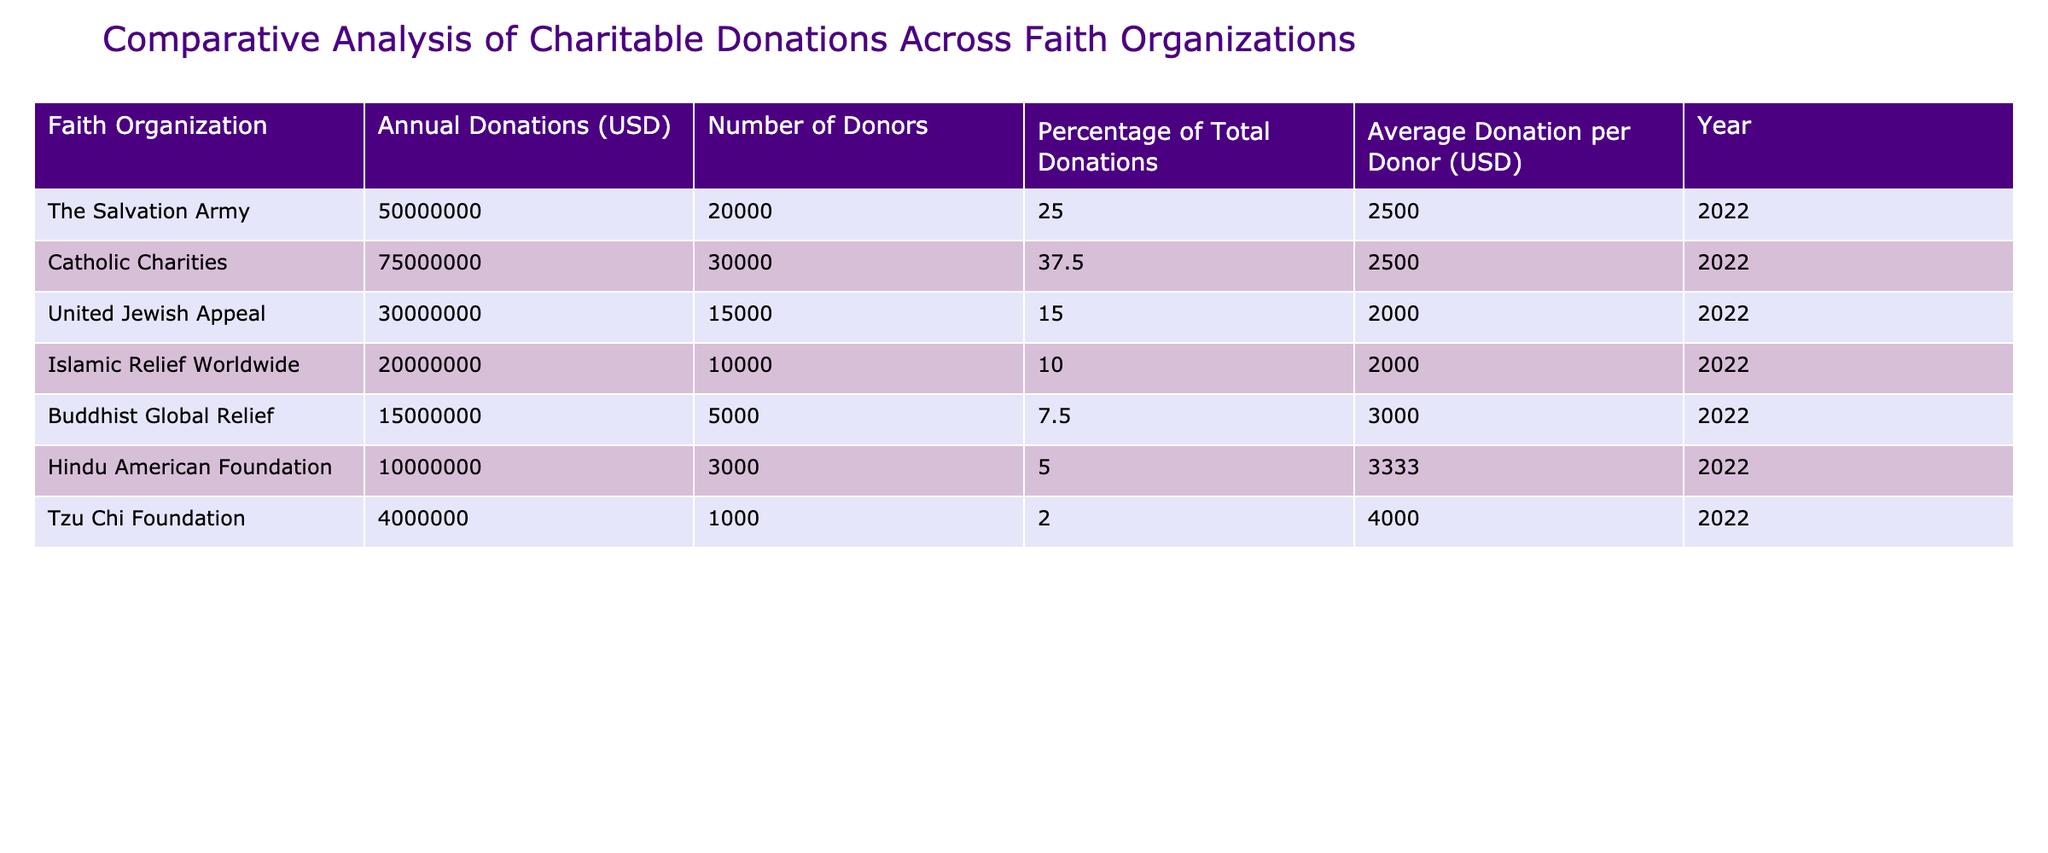What is the total amount of annual donations recorded in the table? To find the total amount of annual donations, add the donations from each organization: 50000000 + 75000000 + 30000000 + 20000000 + 15000000 + 10000000 + 4000000 = 189000000.
Answer: 189000000 Which faith organization received the highest percentage of total donations? By examining the "Percentage of Total Donations" column, Catholic Charities received the highest percentage at 37.5%.
Answer: Catholic Charities What is the average donation per donor for the Tzu Chi Foundation? The average donation per donor for the Tzu Chi Foundation is directly from the table, listed as 4000.
Answer: 4000 Is it true that the Hindu American Foundation has more donors than the Islamic Relief Worldwide? Comparing the "Number of Donors" for both organizations: Hindu American Foundation has 3000 donors and Islamic Relief Worldwide has 10000 donors. Therefore, the statement is false.
Answer: No What is the combined average donation per donor for the top three faith organizations? The top three organizations by annual donations are Catholic Charities (2500), The Salvation Army (2500), and United Jewish Appeal (2000). To find the average, sum those values (2500 + 2500 + 2000 = 7000) and divide by 3, resulting in an average of 2333.33.
Answer: 2333.33 How much more in total donations did the Catholic Charities receive compared to the Tzu Chi Foundation? To find the difference, subtract the total donations of Tzu Chi Foundation (4000000) from Catholic Charities (75000000): 75000000 - 4000000 = 71000000.
Answer: 71000000 What is the total number of donors across all the organizations? Add the "Number of Donors" for each organization: 20000 + 30000 + 15000 + 10000 + 5000 + 3000 + 1000 = 104000.
Answer: 104000 Did the Buddhist Global Relief organization have a greater percentage of total donations than the Hindu American Foundation? Looking at the percentages, Buddhist Global Relief had 7.5% and Hindu American Foundation had 5%, so Buddhist Global Relief had a greater percentage.
Answer: Yes What is the average of the annual donations for the organizations listed in this table? Sum the annual donations (50000000 + 75000000 + 30000000 + 20000000 + 15000000 + 10000000 + 4000000 = 189000000) and divide by the number of organizations (7): 189000000 / 7 = 27000000.
Answer: 27000000 